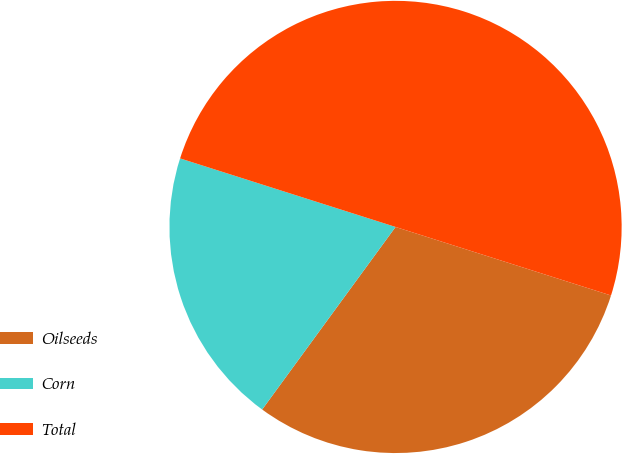Convert chart to OTSL. <chart><loc_0><loc_0><loc_500><loc_500><pie_chart><fcel>Oilseeds<fcel>Corn<fcel>Total<nl><fcel>30.14%<fcel>19.86%<fcel>50.0%<nl></chart> 